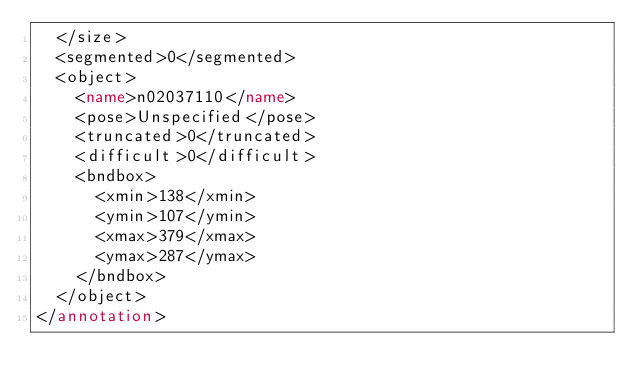<code> <loc_0><loc_0><loc_500><loc_500><_XML_>	</size>
	<segmented>0</segmented>
	<object>
		<name>n02037110</name>
		<pose>Unspecified</pose>
		<truncated>0</truncated>
		<difficult>0</difficult>
		<bndbox>
			<xmin>138</xmin>
			<ymin>107</ymin>
			<xmax>379</xmax>
			<ymax>287</ymax>
		</bndbox>
	</object>
</annotation></code> 